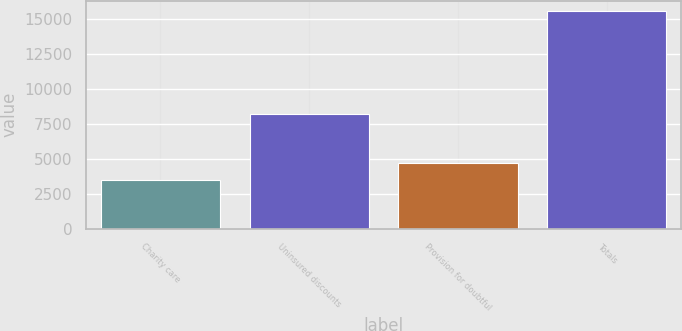<chart> <loc_0><loc_0><loc_500><loc_500><bar_chart><fcel>Charity care<fcel>Uninsured discounts<fcel>Provision for doubtful<fcel>Totals<nl><fcel>3497<fcel>8210<fcel>4703.8<fcel>15565<nl></chart> 